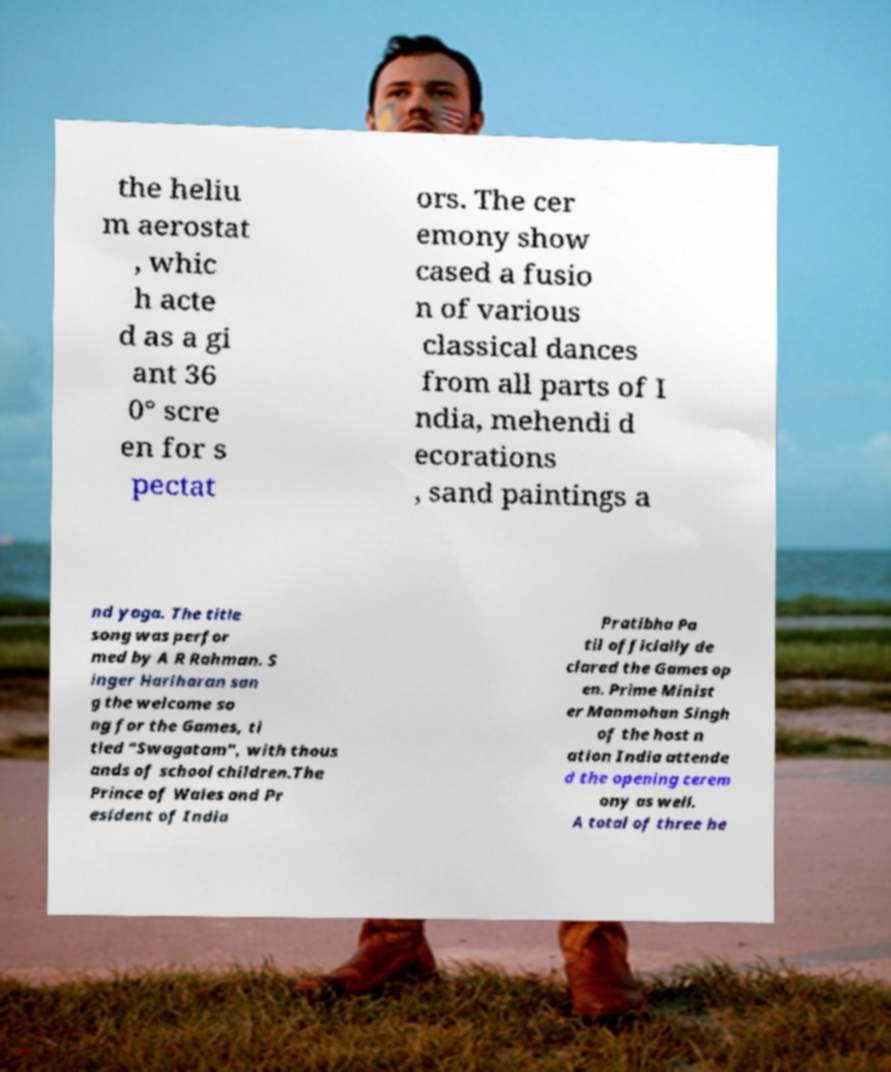Can you read and provide the text displayed in the image?This photo seems to have some interesting text. Can you extract and type it out for me? the heliu m aerostat , whic h acte d as a gi ant 36 0° scre en for s pectat ors. The cer emony show cased a fusio n of various classical dances from all parts of I ndia, mehendi d ecorations , sand paintings a nd yoga. The title song was perfor med by A R Rahman. S inger Hariharan san g the welcome so ng for the Games, ti tled "Swagatam", with thous ands of school children.The Prince of Wales and Pr esident of India Pratibha Pa til officially de clared the Games op en. Prime Minist er Manmohan Singh of the host n ation India attende d the opening cerem ony as well. A total of three he 